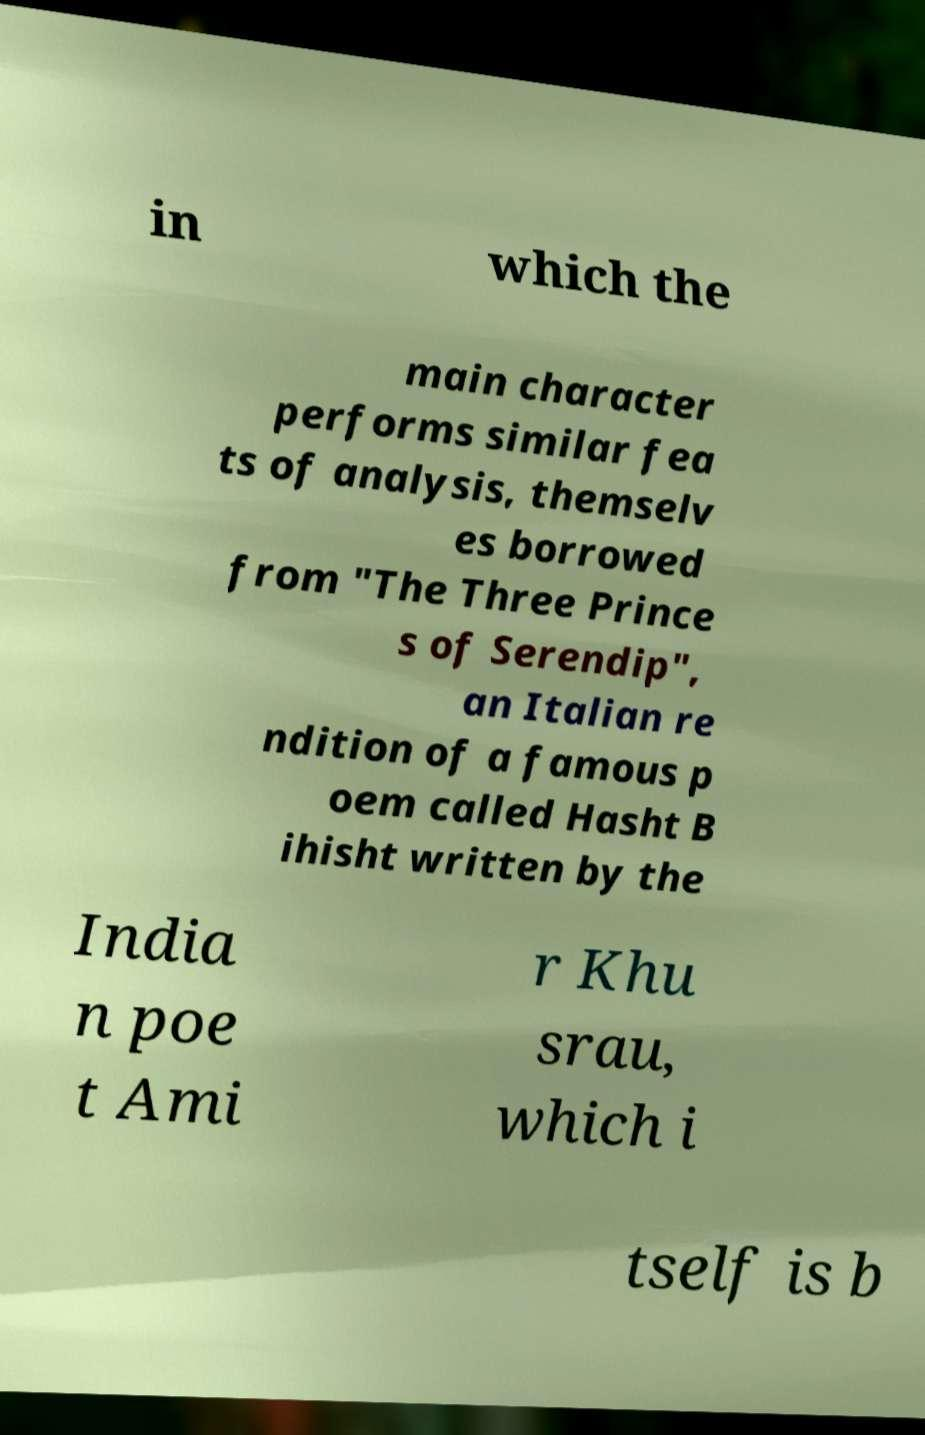Could you extract and type out the text from this image? in which the main character performs similar fea ts of analysis, themselv es borrowed from "The Three Prince s of Serendip", an Italian re ndition of a famous p oem called Hasht B ihisht written by the India n poe t Ami r Khu srau, which i tself is b 